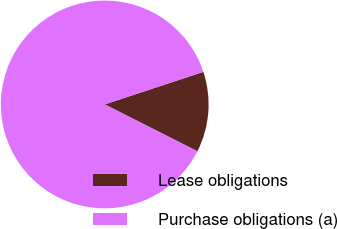<chart> <loc_0><loc_0><loc_500><loc_500><pie_chart><fcel>Lease obligations<fcel>Purchase obligations (a)<nl><fcel>12.53%<fcel>87.47%<nl></chart> 